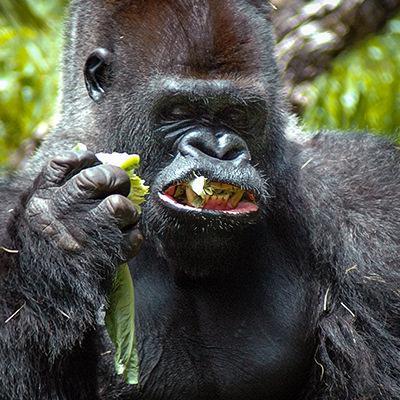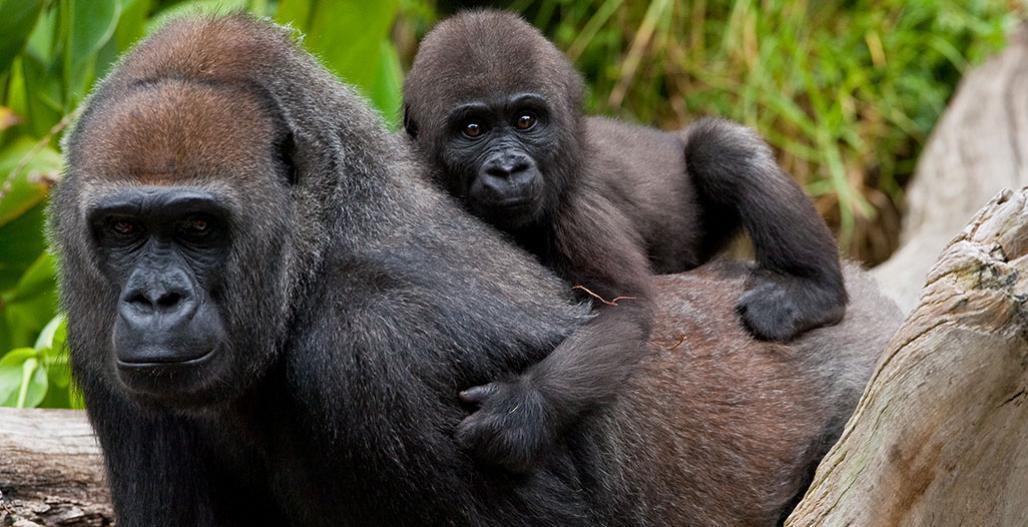The first image is the image on the left, the second image is the image on the right. Evaluate the accuracy of this statement regarding the images: "The left image features an adult male gorilla clutching a leafy green item near its mouth.". Is it true? Answer yes or no. Yes. The first image is the image on the left, the second image is the image on the right. Given the left and right images, does the statement "The right image contains two gorillas." hold true? Answer yes or no. Yes. 